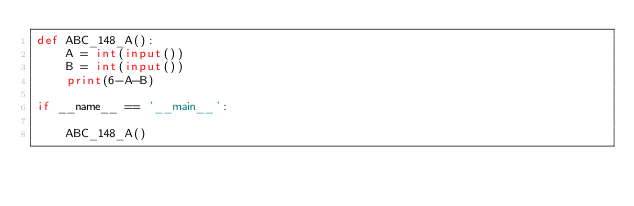Convert code to text. <code><loc_0><loc_0><loc_500><loc_500><_Python_>def ABC_148_A():
    A = int(input())
    B = int(input())
    print(6-A-B)

if __name__ == '__main__':

    ABC_148_A()</code> 